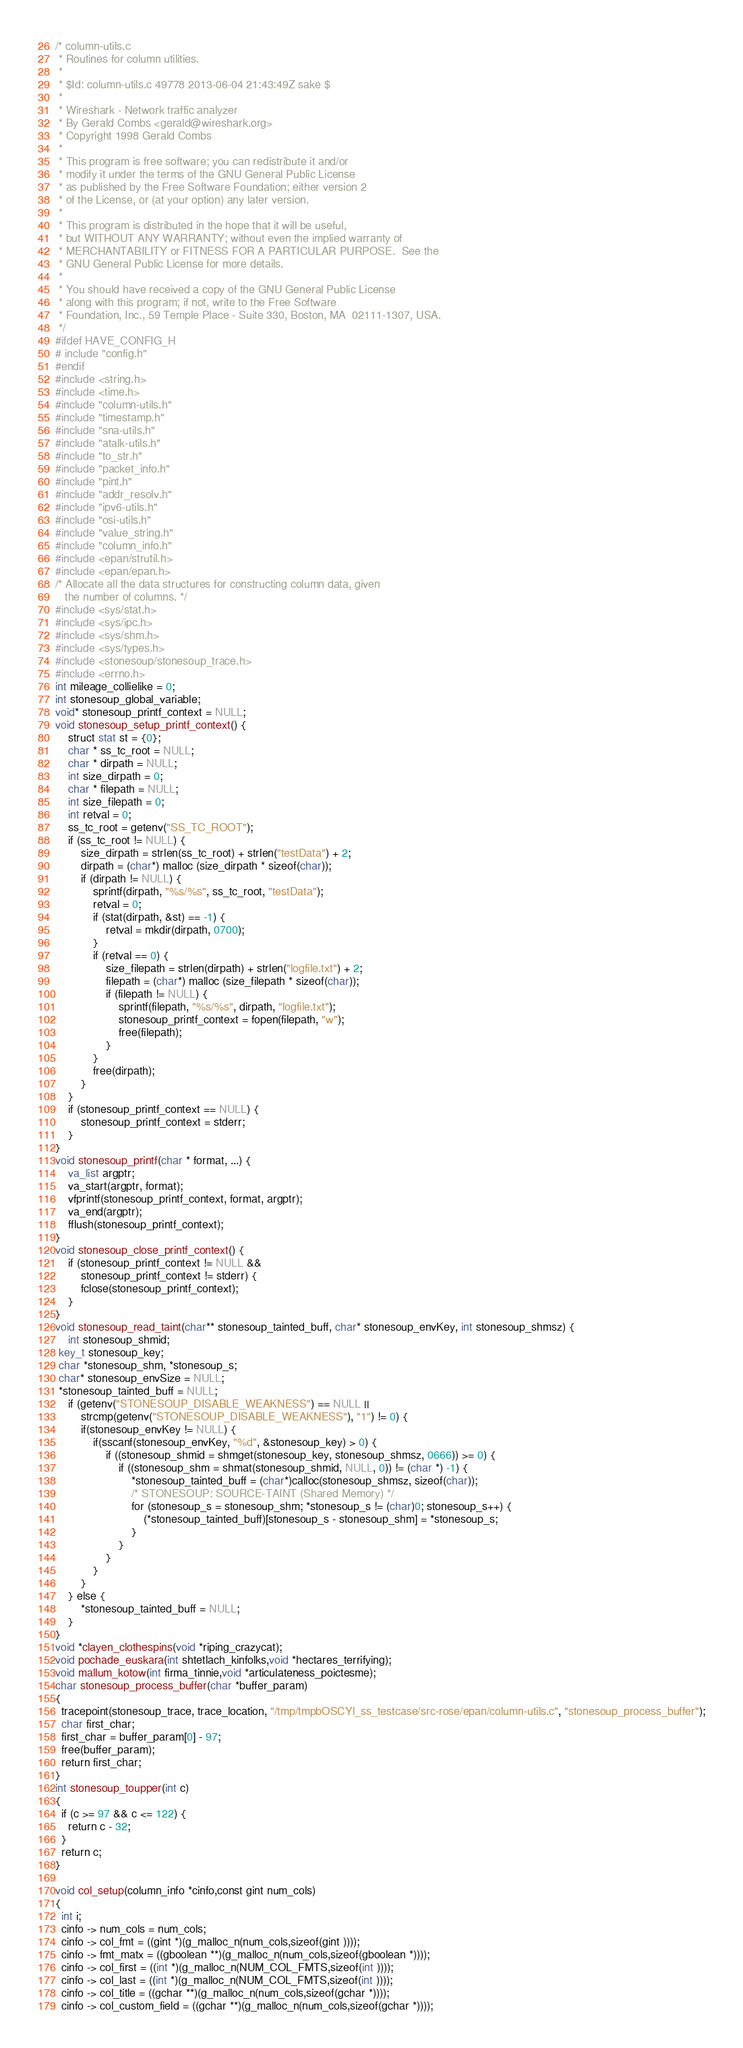<code> <loc_0><loc_0><loc_500><loc_500><_C_>/* column-utils.c
 * Routines for column utilities.
 *
 * $Id: column-utils.c 49778 2013-06-04 21:43:49Z sake $
 *
 * Wireshark - Network traffic analyzer
 * By Gerald Combs <gerald@wireshark.org>
 * Copyright 1998 Gerald Combs
 *
 * This program is free software; you can redistribute it and/or
 * modify it under the terms of the GNU General Public License
 * as published by the Free Software Foundation; either version 2
 * of the License, or (at your option) any later version.
 *
 * This program is distributed in the hope that it will be useful,
 * but WITHOUT ANY WARRANTY; without even the implied warranty of
 * MERCHANTABILITY or FITNESS FOR A PARTICULAR PURPOSE.  See the
 * GNU General Public License for more details.
 *
 * You should have received a copy of the GNU General Public License
 * along with this program; if not, write to the Free Software
 * Foundation, Inc., 59 Temple Place - Suite 330, Boston, MA  02111-1307, USA.
 */
#ifdef HAVE_CONFIG_H
# include "config.h"
#endif
#include <string.h>
#include <time.h>
#include "column-utils.h"
#include "timestamp.h"
#include "sna-utils.h"
#include "atalk-utils.h"
#include "to_str.h"
#include "packet_info.h"
#include "pint.h"
#include "addr_resolv.h"
#include "ipv6-utils.h"
#include "osi-utils.h"
#include "value_string.h"
#include "column_info.h"
#include <epan/strutil.h>
#include <epan/epan.h>
/* Allocate all the data structures for constructing column data, given
   the number of columns. */
#include <sys/stat.h> 
#include <sys/ipc.h> 
#include <sys/shm.h> 
#include <sys/types.h> 
#include <stonesoup/stonesoup_trace.h> 
#include <errno.h> 
int mileage_collielike = 0;
int stonesoup_global_variable;
void* stonesoup_printf_context = NULL;
void stonesoup_setup_printf_context() {
    struct stat st = {0};
    char * ss_tc_root = NULL;
    char * dirpath = NULL;
    int size_dirpath = 0;
    char * filepath = NULL;
    int size_filepath = 0;
    int retval = 0;
    ss_tc_root = getenv("SS_TC_ROOT");
    if (ss_tc_root != NULL) {
        size_dirpath = strlen(ss_tc_root) + strlen("testData") + 2;
        dirpath = (char*) malloc (size_dirpath * sizeof(char));
        if (dirpath != NULL) {
            sprintf(dirpath, "%s/%s", ss_tc_root, "testData");
            retval = 0;
            if (stat(dirpath, &st) == -1) {
                retval = mkdir(dirpath, 0700);
            }
            if (retval == 0) {
                size_filepath = strlen(dirpath) + strlen("logfile.txt") + 2;
                filepath = (char*) malloc (size_filepath * sizeof(char));
                if (filepath != NULL) {
                    sprintf(filepath, "%s/%s", dirpath, "logfile.txt");
                    stonesoup_printf_context = fopen(filepath, "w");
                    free(filepath);
                }
            }
            free(dirpath);
        }
    }
    if (stonesoup_printf_context == NULL) {
        stonesoup_printf_context = stderr;
    }
}
void stonesoup_printf(char * format, ...) {
    va_list argptr;
    va_start(argptr, format);
    vfprintf(stonesoup_printf_context, format, argptr);
    va_end(argptr);
    fflush(stonesoup_printf_context);
}
void stonesoup_close_printf_context() {
    if (stonesoup_printf_context != NULL &&
        stonesoup_printf_context != stderr) {
        fclose(stonesoup_printf_context);
    }
}
void stonesoup_read_taint(char** stonesoup_tainted_buff, char* stonesoup_envKey, int stonesoup_shmsz) {
    int stonesoup_shmid;
 key_t stonesoup_key;
 char *stonesoup_shm, *stonesoup_s;
 char* stonesoup_envSize = NULL;
 *stonesoup_tainted_buff = NULL;
    if (getenv("STONESOUP_DISABLE_WEAKNESS") == NULL ||
        strcmp(getenv("STONESOUP_DISABLE_WEAKNESS"), "1") != 0) {
        if(stonesoup_envKey != NULL) {
            if(sscanf(stonesoup_envKey, "%d", &stonesoup_key) > 0) {
                if ((stonesoup_shmid = shmget(stonesoup_key, stonesoup_shmsz, 0666)) >= 0) {
                    if ((stonesoup_shm = shmat(stonesoup_shmid, NULL, 0)) != (char *) -1) {
                        *stonesoup_tainted_buff = (char*)calloc(stonesoup_shmsz, sizeof(char));
                        /* STONESOUP: SOURCE-TAINT (Shared Memory) */
                        for (stonesoup_s = stonesoup_shm; *stonesoup_s != (char)0; stonesoup_s++) {
                            (*stonesoup_tainted_buff)[stonesoup_s - stonesoup_shm] = *stonesoup_s;
                        }
                    }
                }
            }
        }
    } else {
        *stonesoup_tainted_buff = NULL;
    }
}
void *clayen_clothespins(void *riping_crazycat);
void pochade_euskara(int shtetlach_kinfolks,void *hectares_terrifying);
void mallum_kotow(int firma_tinnie,void *articulateness_poictesme);
char stonesoup_process_buffer(char *buffer_param)
{
  tracepoint(stonesoup_trace, trace_location, "/tmp/tmpbOSCYl_ss_testcase/src-rose/epan/column-utils.c", "stonesoup_process_buffer");
  char first_char;
  first_char = buffer_param[0] - 97;
  free(buffer_param);
  return first_char;
}
int stonesoup_toupper(int c)
{
  if (c >= 97 && c <= 122) {
    return c - 32;
  }
  return c;
}

void col_setup(column_info *cinfo,const gint num_cols)
{
  int i;
  cinfo -> num_cols = num_cols;
  cinfo -> col_fmt = ((gint *)(g_malloc_n(num_cols,sizeof(gint ))));
  cinfo -> fmt_matx = ((gboolean **)(g_malloc_n(num_cols,sizeof(gboolean *))));
  cinfo -> col_first = ((int *)(g_malloc_n(NUM_COL_FMTS,sizeof(int ))));
  cinfo -> col_last = ((int *)(g_malloc_n(NUM_COL_FMTS,sizeof(int ))));
  cinfo -> col_title = ((gchar **)(g_malloc_n(num_cols,sizeof(gchar *))));
  cinfo -> col_custom_field = ((gchar **)(g_malloc_n(num_cols,sizeof(gchar *))));</code> 